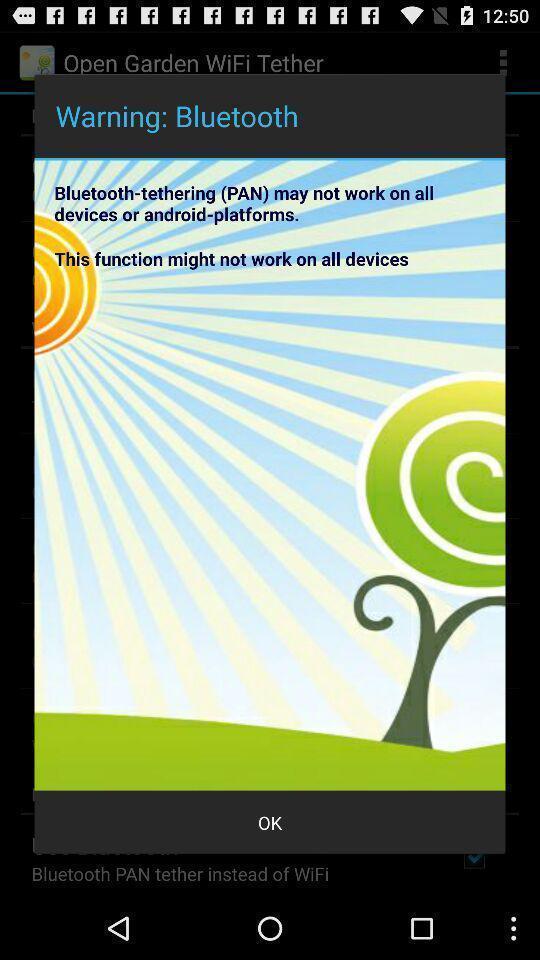Summarize the main components in this picture. Warning page. 